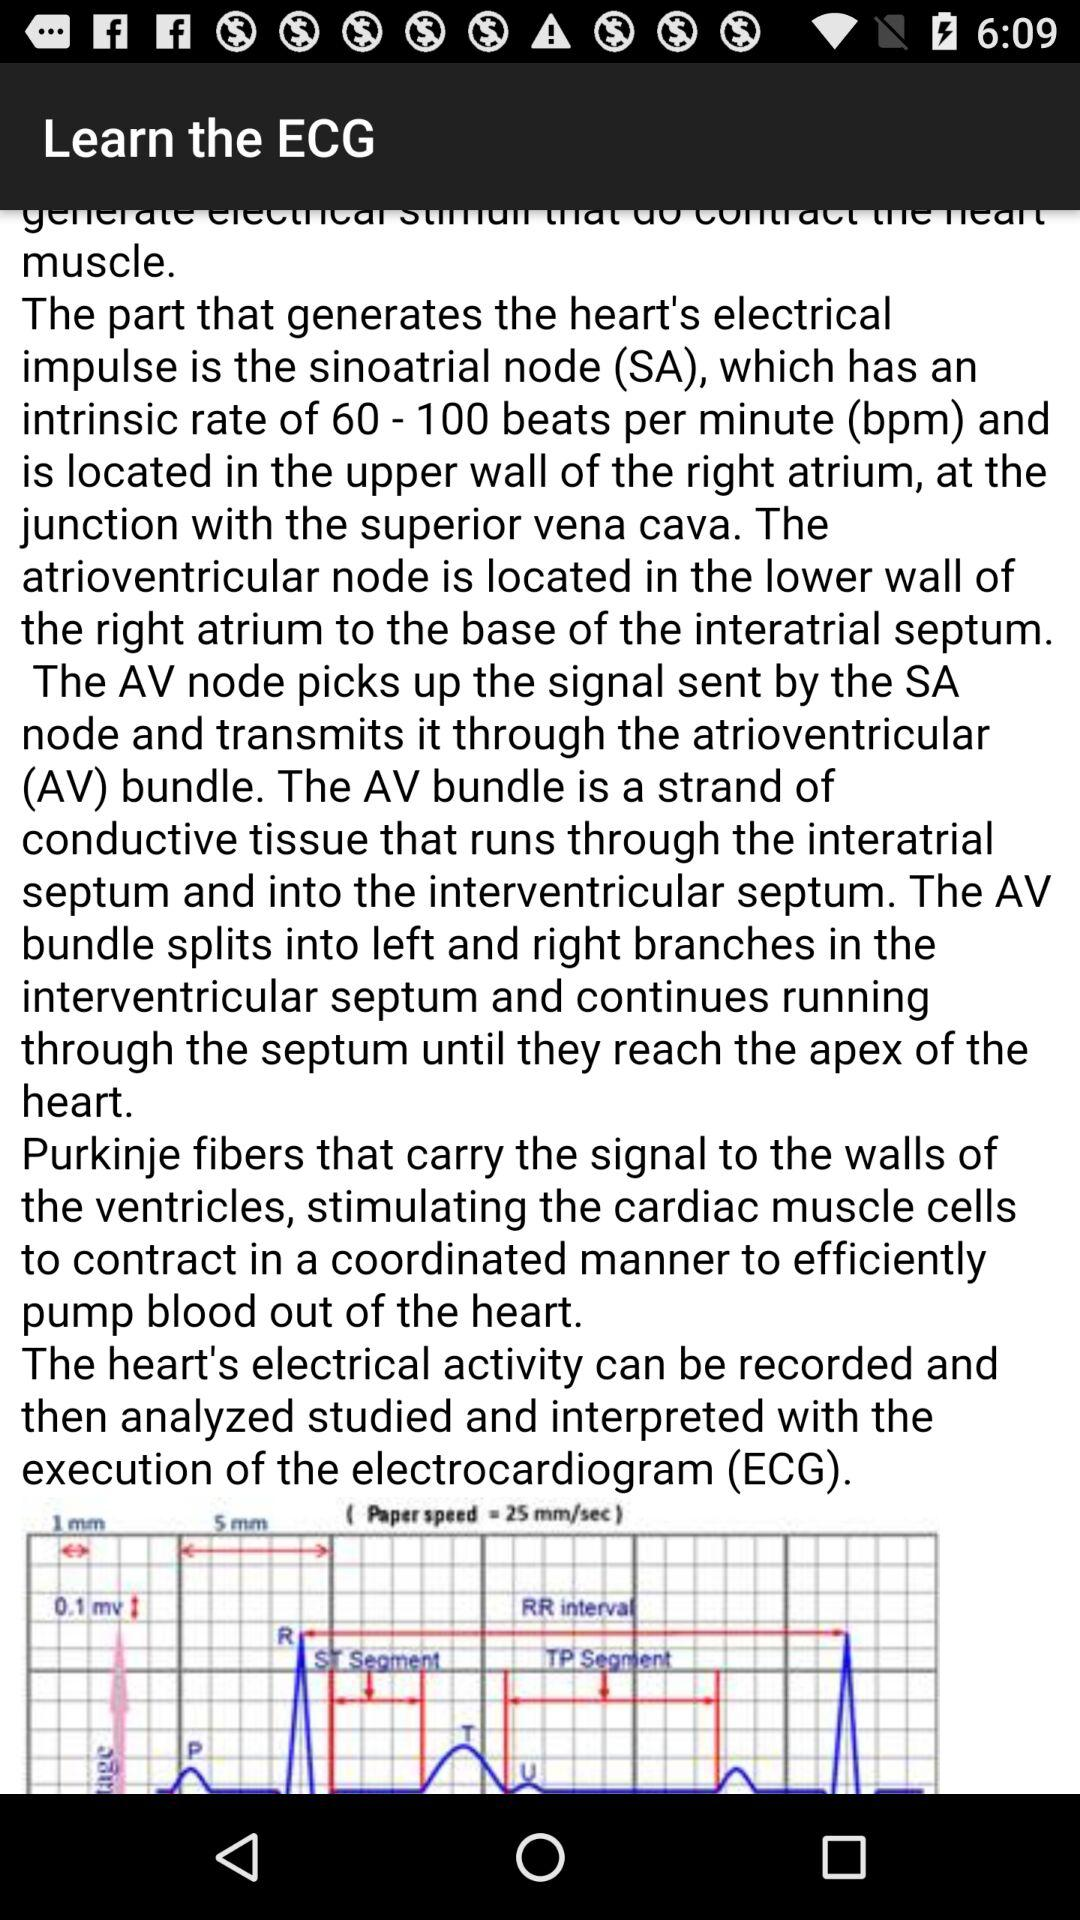What is the email address of the author? The email address of the author is kapelis.aristidis@gmail.com. 